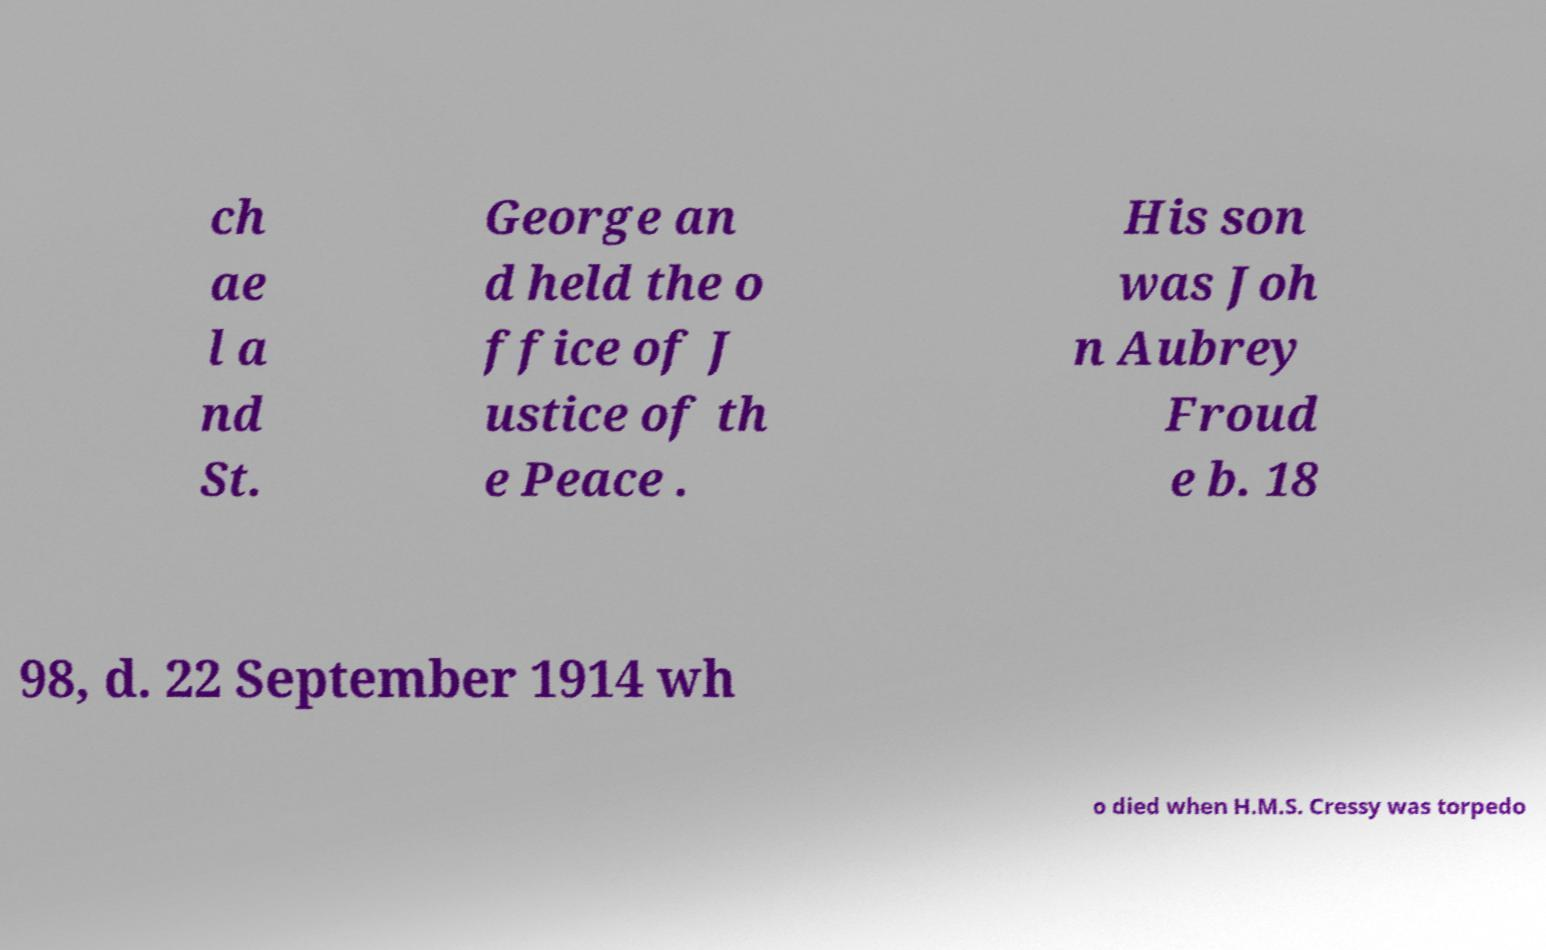I need the written content from this picture converted into text. Can you do that? ch ae l a nd St. George an d held the o ffice of J ustice of th e Peace . His son was Joh n Aubrey Froud e b. 18 98, d. 22 September 1914 wh o died when H.M.S. Cressy was torpedo 